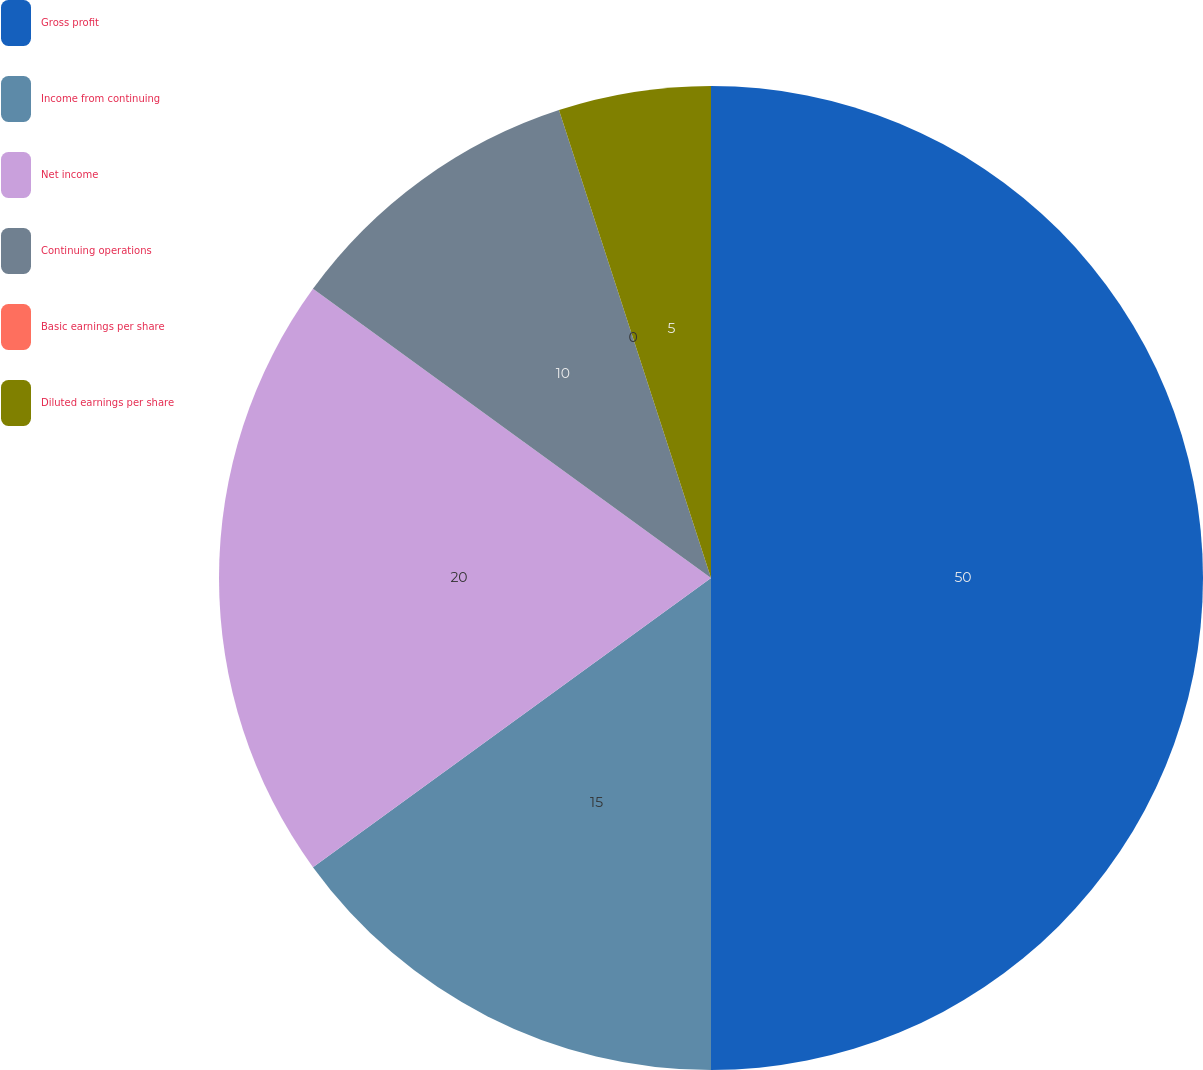<chart> <loc_0><loc_0><loc_500><loc_500><pie_chart><fcel>Gross profit<fcel>Income from continuing<fcel>Net income<fcel>Continuing operations<fcel>Basic earnings per share<fcel>Diluted earnings per share<nl><fcel>50.0%<fcel>15.0%<fcel>20.0%<fcel>10.0%<fcel>0.0%<fcel>5.0%<nl></chart> 